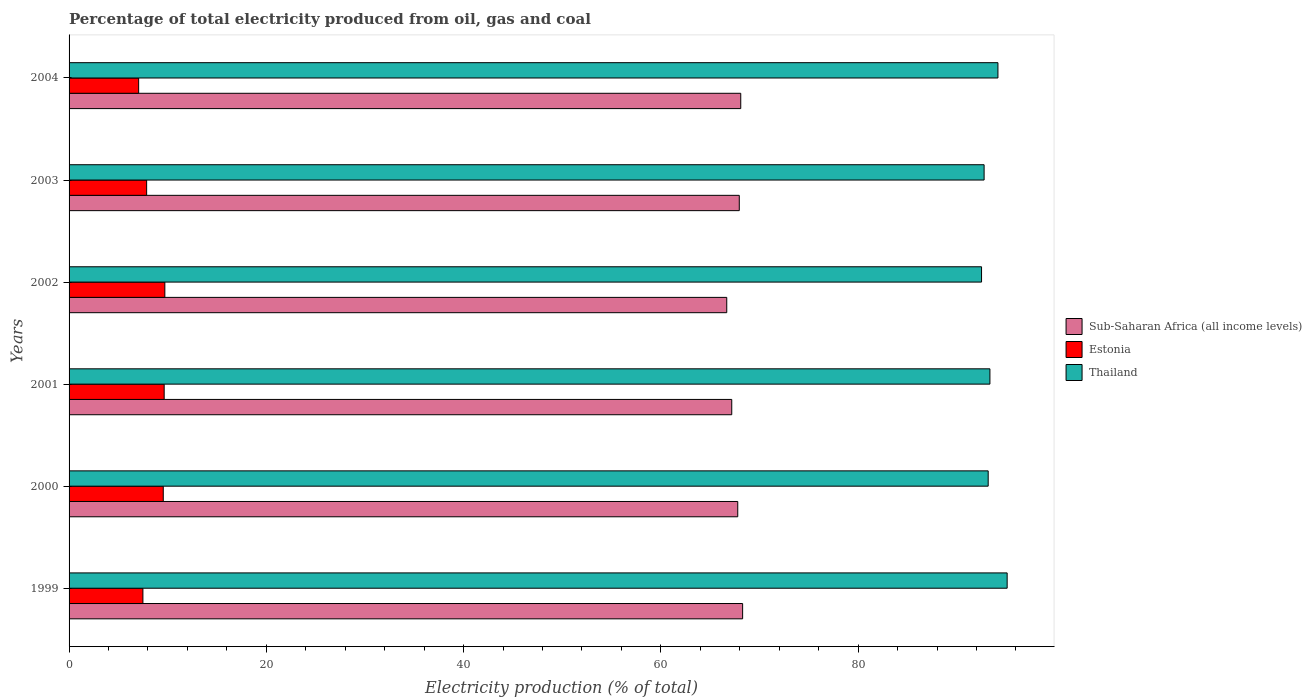How many different coloured bars are there?
Your answer should be very brief. 3. How many groups of bars are there?
Offer a very short reply. 6. Are the number of bars on each tick of the Y-axis equal?
Keep it short and to the point. Yes. What is the electricity production in in Estonia in 2002?
Provide a short and direct response. 9.71. Across all years, what is the maximum electricity production in in Estonia?
Provide a short and direct response. 9.71. Across all years, what is the minimum electricity production in in Thailand?
Provide a short and direct response. 92.52. What is the total electricity production in in Sub-Saharan Africa (all income levels) in the graph?
Offer a very short reply. 406.01. What is the difference between the electricity production in in Thailand in 2003 and that in 2004?
Offer a very short reply. -1.4. What is the difference between the electricity production in in Thailand in 1999 and the electricity production in in Sub-Saharan Africa (all income levels) in 2002?
Give a very brief answer. 28.43. What is the average electricity production in in Estonia per year?
Your answer should be compact. 8.55. In the year 2001, what is the difference between the electricity production in in Estonia and electricity production in in Thailand?
Your answer should be very brief. -83.72. What is the ratio of the electricity production in in Thailand in 1999 to that in 2004?
Your answer should be very brief. 1.01. Is the electricity production in in Thailand in 2001 less than that in 2003?
Your answer should be compact. No. What is the difference between the highest and the second highest electricity production in in Sub-Saharan Africa (all income levels)?
Your response must be concise. 0.19. What is the difference between the highest and the lowest electricity production in in Sub-Saharan Africa (all income levels)?
Offer a terse response. 1.61. Is the sum of the electricity production in in Thailand in 1999 and 2004 greater than the maximum electricity production in in Sub-Saharan Africa (all income levels) across all years?
Ensure brevity in your answer.  Yes. What does the 1st bar from the top in 2001 represents?
Provide a short and direct response. Thailand. What does the 3rd bar from the bottom in 2001 represents?
Offer a terse response. Thailand. What is the difference between two consecutive major ticks on the X-axis?
Offer a terse response. 20. Does the graph contain any zero values?
Your answer should be compact. No. Does the graph contain grids?
Offer a very short reply. No. How many legend labels are there?
Offer a terse response. 3. How are the legend labels stacked?
Provide a succinct answer. Vertical. What is the title of the graph?
Make the answer very short. Percentage of total electricity produced from oil, gas and coal. What is the label or title of the X-axis?
Ensure brevity in your answer.  Electricity production (% of total). What is the Electricity production (% of total) of Sub-Saharan Africa (all income levels) in 1999?
Make the answer very short. 68.29. What is the Electricity production (% of total) in Estonia in 1999?
Make the answer very short. 7.49. What is the Electricity production (% of total) of Thailand in 1999?
Keep it short and to the point. 95.11. What is the Electricity production (% of total) in Sub-Saharan Africa (all income levels) in 2000?
Your response must be concise. 67.8. What is the Electricity production (% of total) in Estonia in 2000?
Your answer should be compact. 9.55. What is the Electricity production (% of total) in Thailand in 2000?
Keep it short and to the point. 93.19. What is the Electricity production (% of total) of Sub-Saharan Africa (all income levels) in 2001?
Make the answer very short. 67.19. What is the Electricity production (% of total) in Estonia in 2001?
Offer a very short reply. 9.64. What is the Electricity production (% of total) of Thailand in 2001?
Keep it short and to the point. 93.36. What is the Electricity production (% of total) of Sub-Saharan Africa (all income levels) in 2002?
Make the answer very short. 66.68. What is the Electricity production (% of total) in Estonia in 2002?
Keep it short and to the point. 9.71. What is the Electricity production (% of total) of Thailand in 2002?
Your answer should be compact. 92.52. What is the Electricity production (% of total) of Sub-Saharan Africa (all income levels) in 2003?
Your response must be concise. 67.95. What is the Electricity production (% of total) of Estonia in 2003?
Provide a succinct answer. 7.86. What is the Electricity production (% of total) in Thailand in 2003?
Keep it short and to the point. 92.78. What is the Electricity production (% of total) of Sub-Saharan Africa (all income levels) in 2004?
Your response must be concise. 68.1. What is the Electricity production (% of total) of Estonia in 2004?
Provide a succinct answer. 7.06. What is the Electricity production (% of total) of Thailand in 2004?
Ensure brevity in your answer.  94.18. Across all years, what is the maximum Electricity production (% of total) in Sub-Saharan Africa (all income levels)?
Give a very brief answer. 68.29. Across all years, what is the maximum Electricity production (% of total) of Estonia?
Make the answer very short. 9.71. Across all years, what is the maximum Electricity production (% of total) in Thailand?
Offer a very short reply. 95.11. Across all years, what is the minimum Electricity production (% of total) of Sub-Saharan Africa (all income levels)?
Offer a terse response. 66.68. Across all years, what is the minimum Electricity production (% of total) of Estonia?
Your response must be concise. 7.06. Across all years, what is the minimum Electricity production (% of total) of Thailand?
Your answer should be compact. 92.52. What is the total Electricity production (% of total) of Sub-Saharan Africa (all income levels) in the graph?
Your answer should be very brief. 406.01. What is the total Electricity production (% of total) of Estonia in the graph?
Make the answer very short. 51.31. What is the total Electricity production (% of total) of Thailand in the graph?
Your answer should be compact. 561.13. What is the difference between the Electricity production (% of total) in Sub-Saharan Africa (all income levels) in 1999 and that in 2000?
Offer a very short reply. 0.49. What is the difference between the Electricity production (% of total) in Estonia in 1999 and that in 2000?
Keep it short and to the point. -2.06. What is the difference between the Electricity production (% of total) in Thailand in 1999 and that in 2000?
Provide a short and direct response. 1.92. What is the difference between the Electricity production (% of total) of Sub-Saharan Africa (all income levels) in 1999 and that in 2001?
Your answer should be compact. 1.1. What is the difference between the Electricity production (% of total) of Estonia in 1999 and that in 2001?
Your answer should be very brief. -2.16. What is the difference between the Electricity production (% of total) of Thailand in 1999 and that in 2001?
Your answer should be very brief. 1.75. What is the difference between the Electricity production (% of total) of Sub-Saharan Africa (all income levels) in 1999 and that in 2002?
Your answer should be very brief. 1.61. What is the difference between the Electricity production (% of total) in Estonia in 1999 and that in 2002?
Make the answer very short. -2.22. What is the difference between the Electricity production (% of total) in Thailand in 1999 and that in 2002?
Your answer should be very brief. 2.6. What is the difference between the Electricity production (% of total) in Sub-Saharan Africa (all income levels) in 1999 and that in 2003?
Your answer should be compact. 0.34. What is the difference between the Electricity production (% of total) of Estonia in 1999 and that in 2003?
Provide a succinct answer. -0.38. What is the difference between the Electricity production (% of total) of Thailand in 1999 and that in 2003?
Provide a succinct answer. 2.34. What is the difference between the Electricity production (% of total) of Sub-Saharan Africa (all income levels) in 1999 and that in 2004?
Offer a terse response. 0.19. What is the difference between the Electricity production (% of total) in Estonia in 1999 and that in 2004?
Provide a succinct answer. 0.43. What is the difference between the Electricity production (% of total) of Thailand in 1999 and that in 2004?
Ensure brevity in your answer.  0.93. What is the difference between the Electricity production (% of total) of Sub-Saharan Africa (all income levels) in 2000 and that in 2001?
Give a very brief answer. 0.61. What is the difference between the Electricity production (% of total) in Estonia in 2000 and that in 2001?
Your answer should be very brief. -0.09. What is the difference between the Electricity production (% of total) of Thailand in 2000 and that in 2001?
Give a very brief answer. -0.17. What is the difference between the Electricity production (% of total) of Sub-Saharan Africa (all income levels) in 2000 and that in 2002?
Offer a terse response. 1.11. What is the difference between the Electricity production (% of total) of Estonia in 2000 and that in 2002?
Make the answer very short. -0.16. What is the difference between the Electricity production (% of total) of Thailand in 2000 and that in 2002?
Keep it short and to the point. 0.67. What is the difference between the Electricity production (% of total) in Sub-Saharan Africa (all income levels) in 2000 and that in 2003?
Provide a succinct answer. -0.15. What is the difference between the Electricity production (% of total) in Estonia in 2000 and that in 2003?
Provide a succinct answer. 1.69. What is the difference between the Electricity production (% of total) in Thailand in 2000 and that in 2003?
Offer a terse response. 0.41. What is the difference between the Electricity production (% of total) in Sub-Saharan Africa (all income levels) in 2000 and that in 2004?
Make the answer very short. -0.3. What is the difference between the Electricity production (% of total) in Estonia in 2000 and that in 2004?
Provide a succinct answer. 2.49. What is the difference between the Electricity production (% of total) in Thailand in 2000 and that in 2004?
Make the answer very short. -0.99. What is the difference between the Electricity production (% of total) of Sub-Saharan Africa (all income levels) in 2001 and that in 2002?
Ensure brevity in your answer.  0.51. What is the difference between the Electricity production (% of total) in Estonia in 2001 and that in 2002?
Offer a terse response. -0.07. What is the difference between the Electricity production (% of total) of Thailand in 2001 and that in 2002?
Your answer should be compact. 0.85. What is the difference between the Electricity production (% of total) in Sub-Saharan Africa (all income levels) in 2001 and that in 2003?
Give a very brief answer. -0.76. What is the difference between the Electricity production (% of total) of Estonia in 2001 and that in 2003?
Offer a terse response. 1.78. What is the difference between the Electricity production (% of total) in Thailand in 2001 and that in 2003?
Offer a terse response. 0.59. What is the difference between the Electricity production (% of total) of Sub-Saharan Africa (all income levels) in 2001 and that in 2004?
Your response must be concise. -0.91. What is the difference between the Electricity production (% of total) of Estonia in 2001 and that in 2004?
Your answer should be very brief. 2.59. What is the difference between the Electricity production (% of total) of Thailand in 2001 and that in 2004?
Your response must be concise. -0.81. What is the difference between the Electricity production (% of total) in Sub-Saharan Africa (all income levels) in 2002 and that in 2003?
Ensure brevity in your answer.  -1.27. What is the difference between the Electricity production (% of total) in Estonia in 2002 and that in 2003?
Offer a very short reply. 1.85. What is the difference between the Electricity production (% of total) in Thailand in 2002 and that in 2003?
Your answer should be very brief. -0.26. What is the difference between the Electricity production (% of total) of Sub-Saharan Africa (all income levels) in 2002 and that in 2004?
Your response must be concise. -1.42. What is the difference between the Electricity production (% of total) in Estonia in 2002 and that in 2004?
Your response must be concise. 2.65. What is the difference between the Electricity production (% of total) of Thailand in 2002 and that in 2004?
Provide a short and direct response. -1.66. What is the difference between the Electricity production (% of total) of Estonia in 2003 and that in 2004?
Your answer should be compact. 0.81. What is the difference between the Electricity production (% of total) of Thailand in 2003 and that in 2004?
Your answer should be very brief. -1.4. What is the difference between the Electricity production (% of total) of Sub-Saharan Africa (all income levels) in 1999 and the Electricity production (% of total) of Estonia in 2000?
Provide a short and direct response. 58.74. What is the difference between the Electricity production (% of total) in Sub-Saharan Africa (all income levels) in 1999 and the Electricity production (% of total) in Thailand in 2000?
Provide a short and direct response. -24.9. What is the difference between the Electricity production (% of total) in Estonia in 1999 and the Electricity production (% of total) in Thailand in 2000?
Offer a terse response. -85.7. What is the difference between the Electricity production (% of total) of Sub-Saharan Africa (all income levels) in 1999 and the Electricity production (% of total) of Estonia in 2001?
Your answer should be compact. 58.65. What is the difference between the Electricity production (% of total) of Sub-Saharan Africa (all income levels) in 1999 and the Electricity production (% of total) of Thailand in 2001?
Your answer should be compact. -25.07. What is the difference between the Electricity production (% of total) in Estonia in 1999 and the Electricity production (% of total) in Thailand in 2001?
Give a very brief answer. -85.88. What is the difference between the Electricity production (% of total) in Sub-Saharan Africa (all income levels) in 1999 and the Electricity production (% of total) in Estonia in 2002?
Offer a terse response. 58.58. What is the difference between the Electricity production (% of total) of Sub-Saharan Africa (all income levels) in 1999 and the Electricity production (% of total) of Thailand in 2002?
Offer a very short reply. -24.22. What is the difference between the Electricity production (% of total) of Estonia in 1999 and the Electricity production (% of total) of Thailand in 2002?
Your response must be concise. -85.03. What is the difference between the Electricity production (% of total) of Sub-Saharan Africa (all income levels) in 1999 and the Electricity production (% of total) of Estonia in 2003?
Keep it short and to the point. 60.43. What is the difference between the Electricity production (% of total) in Sub-Saharan Africa (all income levels) in 1999 and the Electricity production (% of total) in Thailand in 2003?
Provide a short and direct response. -24.48. What is the difference between the Electricity production (% of total) of Estonia in 1999 and the Electricity production (% of total) of Thailand in 2003?
Your answer should be compact. -85.29. What is the difference between the Electricity production (% of total) in Sub-Saharan Africa (all income levels) in 1999 and the Electricity production (% of total) in Estonia in 2004?
Provide a succinct answer. 61.24. What is the difference between the Electricity production (% of total) of Sub-Saharan Africa (all income levels) in 1999 and the Electricity production (% of total) of Thailand in 2004?
Ensure brevity in your answer.  -25.89. What is the difference between the Electricity production (% of total) in Estonia in 1999 and the Electricity production (% of total) in Thailand in 2004?
Your answer should be compact. -86.69. What is the difference between the Electricity production (% of total) of Sub-Saharan Africa (all income levels) in 2000 and the Electricity production (% of total) of Estonia in 2001?
Offer a terse response. 58.15. What is the difference between the Electricity production (% of total) of Sub-Saharan Africa (all income levels) in 2000 and the Electricity production (% of total) of Thailand in 2001?
Ensure brevity in your answer.  -25.57. What is the difference between the Electricity production (% of total) of Estonia in 2000 and the Electricity production (% of total) of Thailand in 2001?
Your answer should be very brief. -83.81. What is the difference between the Electricity production (% of total) of Sub-Saharan Africa (all income levels) in 2000 and the Electricity production (% of total) of Estonia in 2002?
Offer a terse response. 58.09. What is the difference between the Electricity production (% of total) in Sub-Saharan Africa (all income levels) in 2000 and the Electricity production (% of total) in Thailand in 2002?
Offer a terse response. -24.72. What is the difference between the Electricity production (% of total) of Estonia in 2000 and the Electricity production (% of total) of Thailand in 2002?
Your response must be concise. -82.97. What is the difference between the Electricity production (% of total) of Sub-Saharan Africa (all income levels) in 2000 and the Electricity production (% of total) of Estonia in 2003?
Make the answer very short. 59.93. What is the difference between the Electricity production (% of total) of Sub-Saharan Africa (all income levels) in 2000 and the Electricity production (% of total) of Thailand in 2003?
Your answer should be very brief. -24.98. What is the difference between the Electricity production (% of total) in Estonia in 2000 and the Electricity production (% of total) in Thailand in 2003?
Your answer should be compact. -83.22. What is the difference between the Electricity production (% of total) of Sub-Saharan Africa (all income levels) in 2000 and the Electricity production (% of total) of Estonia in 2004?
Make the answer very short. 60.74. What is the difference between the Electricity production (% of total) of Sub-Saharan Africa (all income levels) in 2000 and the Electricity production (% of total) of Thailand in 2004?
Ensure brevity in your answer.  -26.38. What is the difference between the Electricity production (% of total) in Estonia in 2000 and the Electricity production (% of total) in Thailand in 2004?
Provide a short and direct response. -84.63. What is the difference between the Electricity production (% of total) of Sub-Saharan Africa (all income levels) in 2001 and the Electricity production (% of total) of Estonia in 2002?
Provide a succinct answer. 57.48. What is the difference between the Electricity production (% of total) of Sub-Saharan Africa (all income levels) in 2001 and the Electricity production (% of total) of Thailand in 2002?
Your answer should be very brief. -25.33. What is the difference between the Electricity production (% of total) of Estonia in 2001 and the Electricity production (% of total) of Thailand in 2002?
Your answer should be very brief. -82.87. What is the difference between the Electricity production (% of total) in Sub-Saharan Africa (all income levels) in 2001 and the Electricity production (% of total) in Estonia in 2003?
Your answer should be compact. 59.32. What is the difference between the Electricity production (% of total) of Sub-Saharan Africa (all income levels) in 2001 and the Electricity production (% of total) of Thailand in 2003?
Offer a terse response. -25.59. What is the difference between the Electricity production (% of total) of Estonia in 2001 and the Electricity production (% of total) of Thailand in 2003?
Offer a very short reply. -83.13. What is the difference between the Electricity production (% of total) of Sub-Saharan Africa (all income levels) in 2001 and the Electricity production (% of total) of Estonia in 2004?
Give a very brief answer. 60.13. What is the difference between the Electricity production (% of total) of Sub-Saharan Africa (all income levels) in 2001 and the Electricity production (% of total) of Thailand in 2004?
Offer a very short reply. -26.99. What is the difference between the Electricity production (% of total) of Estonia in 2001 and the Electricity production (% of total) of Thailand in 2004?
Your answer should be compact. -84.53. What is the difference between the Electricity production (% of total) in Sub-Saharan Africa (all income levels) in 2002 and the Electricity production (% of total) in Estonia in 2003?
Give a very brief answer. 58.82. What is the difference between the Electricity production (% of total) in Sub-Saharan Africa (all income levels) in 2002 and the Electricity production (% of total) in Thailand in 2003?
Give a very brief answer. -26.09. What is the difference between the Electricity production (% of total) of Estonia in 2002 and the Electricity production (% of total) of Thailand in 2003?
Give a very brief answer. -83.06. What is the difference between the Electricity production (% of total) in Sub-Saharan Africa (all income levels) in 2002 and the Electricity production (% of total) in Estonia in 2004?
Make the answer very short. 59.63. What is the difference between the Electricity production (% of total) in Sub-Saharan Africa (all income levels) in 2002 and the Electricity production (% of total) in Thailand in 2004?
Offer a very short reply. -27.49. What is the difference between the Electricity production (% of total) of Estonia in 2002 and the Electricity production (% of total) of Thailand in 2004?
Provide a succinct answer. -84.47. What is the difference between the Electricity production (% of total) of Sub-Saharan Africa (all income levels) in 2003 and the Electricity production (% of total) of Estonia in 2004?
Your response must be concise. 60.9. What is the difference between the Electricity production (% of total) of Sub-Saharan Africa (all income levels) in 2003 and the Electricity production (% of total) of Thailand in 2004?
Your answer should be compact. -26.23. What is the difference between the Electricity production (% of total) in Estonia in 2003 and the Electricity production (% of total) in Thailand in 2004?
Your answer should be very brief. -86.31. What is the average Electricity production (% of total) of Sub-Saharan Africa (all income levels) per year?
Offer a very short reply. 67.67. What is the average Electricity production (% of total) in Estonia per year?
Your response must be concise. 8.55. What is the average Electricity production (% of total) in Thailand per year?
Offer a terse response. 93.52. In the year 1999, what is the difference between the Electricity production (% of total) in Sub-Saharan Africa (all income levels) and Electricity production (% of total) in Estonia?
Keep it short and to the point. 60.8. In the year 1999, what is the difference between the Electricity production (% of total) in Sub-Saharan Africa (all income levels) and Electricity production (% of total) in Thailand?
Your response must be concise. -26.82. In the year 1999, what is the difference between the Electricity production (% of total) in Estonia and Electricity production (% of total) in Thailand?
Your answer should be very brief. -87.62. In the year 2000, what is the difference between the Electricity production (% of total) of Sub-Saharan Africa (all income levels) and Electricity production (% of total) of Estonia?
Your answer should be very brief. 58.25. In the year 2000, what is the difference between the Electricity production (% of total) in Sub-Saharan Africa (all income levels) and Electricity production (% of total) in Thailand?
Offer a terse response. -25.39. In the year 2000, what is the difference between the Electricity production (% of total) in Estonia and Electricity production (% of total) in Thailand?
Make the answer very short. -83.64. In the year 2001, what is the difference between the Electricity production (% of total) in Sub-Saharan Africa (all income levels) and Electricity production (% of total) in Estonia?
Your answer should be compact. 57.55. In the year 2001, what is the difference between the Electricity production (% of total) in Sub-Saharan Africa (all income levels) and Electricity production (% of total) in Thailand?
Your answer should be compact. -26.17. In the year 2001, what is the difference between the Electricity production (% of total) of Estonia and Electricity production (% of total) of Thailand?
Provide a short and direct response. -83.72. In the year 2002, what is the difference between the Electricity production (% of total) in Sub-Saharan Africa (all income levels) and Electricity production (% of total) in Estonia?
Give a very brief answer. 56.97. In the year 2002, what is the difference between the Electricity production (% of total) of Sub-Saharan Africa (all income levels) and Electricity production (% of total) of Thailand?
Keep it short and to the point. -25.83. In the year 2002, what is the difference between the Electricity production (% of total) of Estonia and Electricity production (% of total) of Thailand?
Your answer should be very brief. -82.81. In the year 2003, what is the difference between the Electricity production (% of total) of Sub-Saharan Africa (all income levels) and Electricity production (% of total) of Estonia?
Offer a very short reply. 60.09. In the year 2003, what is the difference between the Electricity production (% of total) of Sub-Saharan Africa (all income levels) and Electricity production (% of total) of Thailand?
Offer a terse response. -24.82. In the year 2003, what is the difference between the Electricity production (% of total) of Estonia and Electricity production (% of total) of Thailand?
Provide a short and direct response. -84.91. In the year 2004, what is the difference between the Electricity production (% of total) in Sub-Saharan Africa (all income levels) and Electricity production (% of total) in Estonia?
Make the answer very short. 61.05. In the year 2004, what is the difference between the Electricity production (% of total) of Sub-Saharan Africa (all income levels) and Electricity production (% of total) of Thailand?
Your response must be concise. -26.07. In the year 2004, what is the difference between the Electricity production (% of total) in Estonia and Electricity production (% of total) in Thailand?
Your answer should be compact. -87.12. What is the ratio of the Electricity production (% of total) of Sub-Saharan Africa (all income levels) in 1999 to that in 2000?
Your response must be concise. 1.01. What is the ratio of the Electricity production (% of total) of Estonia in 1999 to that in 2000?
Keep it short and to the point. 0.78. What is the ratio of the Electricity production (% of total) of Thailand in 1999 to that in 2000?
Keep it short and to the point. 1.02. What is the ratio of the Electricity production (% of total) in Sub-Saharan Africa (all income levels) in 1999 to that in 2001?
Your answer should be very brief. 1.02. What is the ratio of the Electricity production (% of total) in Estonia in 1999 to that in 2001?
Your answer should be compact. 0.78. What is the ratio of the Electricity production (% of total) of Thailand in 1999 to that in 2001?
Provide a short and direct response. 1.02. What is the ratio of the Electricity production (% of total) of Sub-Saharan Africa (all income levels) in 1999 to that in 2002?
Your answer should be very brief. 1.02. What is the ratio of the Electricity production (% of total) of Estonia in 1999 to that in 2002?
Provide a short and direct response. 0.77. What is the ratio of the Electricity production (% of total) of Thailand in 1999 to that in 2002?
Your response must be concise. 1.03. What is the ratio of the Electricity production (% of total) of Sub-Saharan Africa (all income levels) in 1999 to that in 2003?
Give a very brief answer. 1. What is the ratio of the Electricity production (% of total) of Estonia in 1999 to that in 2003?
Provide a short and direct response. 0.95. What is the ratio of the Electricity production (% of total) in Thailand in 1999 to that in 2003?
Your response must be concise. 1.03. What is the ratio of the Electricity production (% of total) of Estonia in 1999 to that in 2004?
Your response must be concise. 1.06. What is the ratio of the Electricity production (% of total) in Thailand in 1999 to that in 2004?
Give a very brief answer. 1.01. What is the ratio of the Electricity production (% of total) in Sub-Saharan Africa (all income levels) in 2000 to that in 2001?
Your answer should be very brief. 1.01. What is the ratio of the Electricity production (% of total) of Thailand in 2000 to that in 2001?
Offer a terse response. 1. What is the ratio of the Electricity production (% of total) in Sub-Saharan Africa (all income levels) in 2000 to that in 2002?
Offer a terse response. 1.02. What is the ratio of the Electricity production (% of total) in Estonia in 2000 to that in 2002?
Your answer should be very brief. 0.98. What is the ratio of the Electricity production (% of total) of Thailand in 2000 to that in 2002?
Provide a short and direct response. 1.01. What is the ratio of the Electricity production (% of total) in Estonia in 2000 to that in 2003?
Your answer should be very brief. 1.21. What is the ratio of the Electricity production (% of total) of Thailand in 2000 to that in 2003?
Provide a short and direct response. 1. What is the ratio of the Electricity production (% of total) of Estonia in 2000 to that in 2004?
Offer a very short reply. 1.35. What is the ratio of the Electricity production (% of total) in Sub-Saharan Africa (all income levels) in 2001 to that in 2002?
Offer a terse response. 1.01. What is the ratio of the Electricity production (% of total) of Thailand in 2001 to that in 2002?
Your answer should be compact. 1.01. What is the ratio of the Electricity production (% of total) in Estonia in 2001 to that in 2003?
Offer a very short reply. 1.23. What is the ratio of the Electricity production (% of total) of Sub-Saharan Africa (all income levels) in 2001 to that in 2004?
Offer a very short reply. 0.99. What is the ratio of the Electricity production (% of total) of Estonia in 2001 to that in 2004?
Your response must be concise. 1.37. What is the ratio of the Electricity production (% of total) in Sub-Saharan Africa (all income levels) in 2002 to that in 2003?
Offer a very short reply. 0.98. What is the ratio of the Electricity production (% of total) in Estonia in 2002 to that in 2003?
Provide a succinct answer. 1.23. What is the ratio of the Electricity production (% of total) in Thailand in 2002 to that in 2003?
Your answer should be very brief. 1. What is the ratio of the Electricity production (% of total) in Sub-Saharan Africa (all income levels) in 2002 to that in 2004?
Offer a terse response. 0.98. What is the ratio of the Electricity production (% of total) in Estonia in 2002 to that in 2004?
Your response must be concise. 1.38. What is the ratio of the Electricity production (% of total) in Thailand in 2002 to that in 2004?
Provide a succinct answer. 0.98. What is the ratio of the Electricity production (% of total) in Sub-Saharan Africa (all income levels) in 2003 to that in 2004?
Give a very brief answer. 1. What is the ratio of the Electricity production (% of total) in Estonia in 2003 to that in 2004?
Offer a very short reply. 1.11. What is the ratio of the Electricity production (% of total) of Thailand in 2003 to that in 2004?
Offer a very short reply. 0.99. What is the difference between the highest and the second highest Electricity production (% of total) of Sub-Saharan Africa (all income levels)?
Keep it short and to the point. 0.19. What is the difference between the highest and the second highest Electricity production (% of total) of Estonia?
Your answer should be very brief. 0.07. What is the difference between the highest and the second highest Electricity production (% of total) in Thailand?
Provide a succinct answer. 0.93. What is the difference between the highest and the lowest Electricity production (% of total) in Sub-Saharan Africa (all income levels)?
Ensure brevity in your answer.  1.61. What is the difference between the highest and the lowest Electricity production (% of total) of Estonia?
Make the answer very short. 2.65. What is the difference between the highest and the lowest Electricity production (% of total) of Thailand?
Offer a terse response. 2.6. 